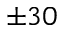<formula> <loc_0><loc_0><loc_500><loc_500>\pm 3 0</formula> 